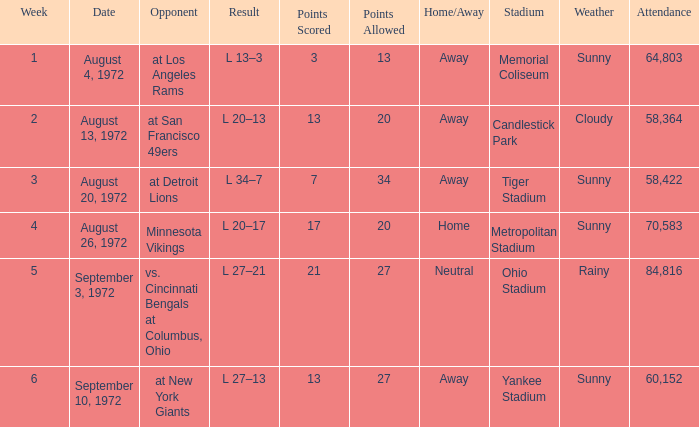What is the date of week 4? August 26, 1972. Give me the full table as a dictionary. {'header': ['Week', 'Date', 'Opponent', 'Result', 'Points Scored', 'Points Allowed', 'Home/Away', 'Stadium', 'Weather', 'Attendance'], 'rows': [['1', 'August 4, 1972', 'at Los Angeles Rams', 'L 13–3', '3', '13', 'Away', 'Memorial Coliseum', 'Sunny', '64,803'], ['2', 'August 13, 1972', 'at San Francisco 49ers', 'L 20–13', '13', '20', 'Away', 'Candlestick Park', 'Cloudy', '58,364'], ['3', 'August 20, 1972', 'at Detroit Lions', 'L 34–7', '7', '34', 'Away', 'Tiger Stadium', 'Sunny', '58,422'], ['4', 'August 26, 1972', 'Minnesota Vikings', 'L 20–17', '17', '20', 'Home', 'Metropolitan Stadium', 'Sunny', '70,583'], ['5', 'September 3, 1972', 'vs. Cincinnati Bengals at Columbus, Ohio', 'L 27–21', '21', '27', 'Neutral', 'Ohio Stadium', 'Rainy', '84,816'], ['6', 'September 10, 1972', 'at New York Giants', 'L 27–13', '13', '27', 'Away', 'Yankee Stadium', 'Sunny', '60,152']]} 